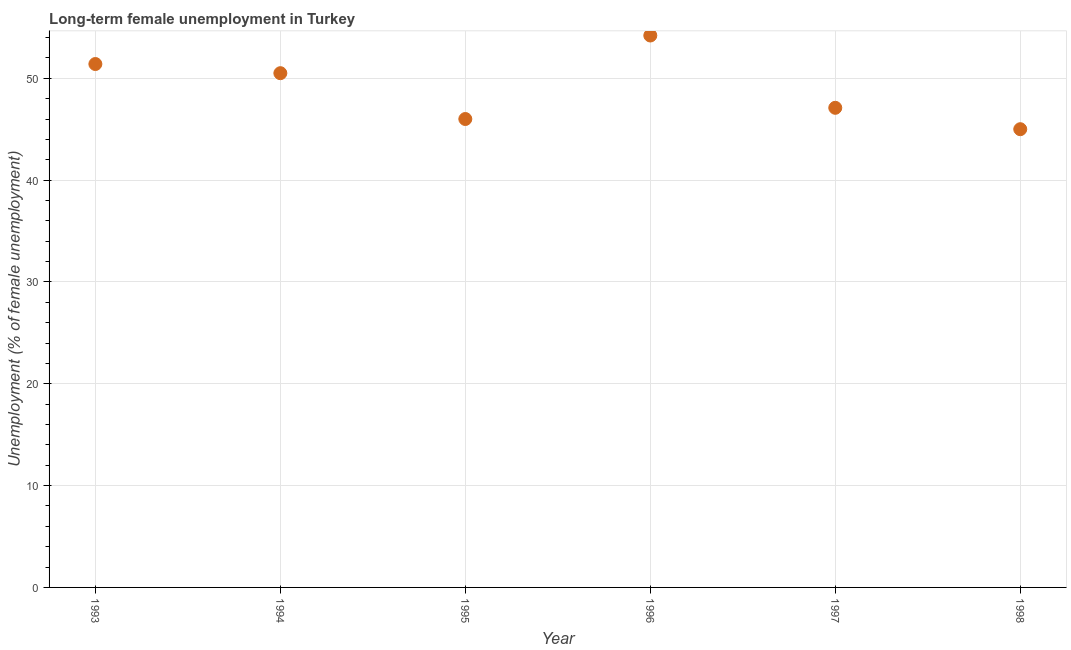Across all years, what is the maximum long-term female unemployment?
Your answer should be very brief. 54.2. Across all years, what is the minimum long-term female unemployment?
Provide a succinct answer. 45. In which year was the long-term female unemployment maximum?
Ensure brevity in your answer.  1996. What is the sum of the long-term female unemployment?
Keep it short and to the point. 294.2. What is the difference between the long-term female unemployment in 1996 and 1998?
Your answer should be compact. 9.2. What is the average long-term female unemployment per year?
Your answer should be compact. 49.03. What is the median long-term female unemployment?
Provide a short and direct response. 48.8. In how many years, is the long-term female unemployment greater than 34 %?
Ensure brevity in your answer.  6. Do a majority of the years between 1996 and 1993 (inclusive) have long-term female unemployment greater than 18 %?
Offer a terse response. Yes. What is the ratio of the long-term female unemployment in 1993 to that in 1997?
Offer a very short reply. 1.09. Is the long-term female unemployment in 1993 less than that in 1995?
Provide a short and direct response. No. What is the difference between the highest and the second highest long-term female unemployment?
Your answer should be very brief. 2.8. What is the difference between the highest and the lowest long-term female unemployment?
Your answer should be compact. 9.2. How many years are there in the graph?
Provide a short and direct response. 6. Are the values on the major ticks of Y-axis written in scientific E-notation?
Your answer should be very brief. No. What is the title of the graph?
Provide a succinct answer. Long-term female unemployment in Turkey. What is the label or title of the X-axis?
Offer a terse response. Year. What is the label or title of the Y-axis?
Give a very brief answer. Unemployment (% of female unemployment). What is the Unemployment (% of female unemployment) in 1993?
Your answer should be compact. 51.4. What is the Unemployment (% of female unemployment) in 1994?
Provide a short and direct response. 50.5. What is the Unemployment (% of female unemployment) in 1995?
Offer a very short reply. 46. What is the Unemployment (% of female unemployment) in 1996?
Ensure brevity in your answer.  54.2. What is the Unemployment (% of female unemployment) in 1997?
Ensure brevity in your answer.  47.1. What is the Unemployment (% of female unemployment) in 1998?
Offer a very short reply. 45. What is the difference between the Unemployment (% of female unemployment) in 1993 and 1995?
Provide a short and direct response. 5.4. What is the difference between the Unemployment (% of female unemployment) in 1993 and 1996?
Provide a succinct answer. -2.8. What is the difference between the Unemployment (% of female unemployment) in 1993 and 1998?
Give a very brief answer. 6.4. What is the difference between the Unemployment (% of female unemployment) in 1994 and 1995?
Offer a terse response. 4.5. What is the difference between the Unemployment (% of female unemployment) in 1994 and 1998?
Keep it short and to the point. 5.5. What is the difference between the Unemployment (% of female unemployment) in 1995 and 1996?
Offer a terse response. -8.2. What is the difference between the Unemployment (% of female unemployment) in 1996 and 1998?
Your response must be concise. 9.2. What is the difference between the Unemployment (% of female unemployment) in 1997 and 1998?
Your response must be concise. 2.1. What is the ratio of the Unemployment (% of female unemployment) in 1993 to that in 1995?
Provide a short and direct response. 1.12. What is the ratio of the Unemployment (% of female unemployment) in 1993 to that in 1996?
Your answer should be compact. 0.95. What is the ratio of the Unemployment (% of female unemployment) in 1993 to that in 1997?
Your answer should be very brief. 1.09. What is the ratio of the Unemployment (% of female unemployment) in 1993 to that in 1998?
Your response must be concise. 1.14. What is the ratio of the Unemployment (% of female unemployment) in 1994 to that in 1995?
Your answer should be very brief. 1.1. What is the ratio of the Unemployment (% of female unemployment) in 1994 to that in 1996?
Provide a short and direct response. 0.93. What is the ratio of the Unemployment (% of female unemployment) in 1994 to that in 1997?
Offer a terse response. 1.07. What is the ratio of the Unemployment (% of female unemployment) in 1994 to that in 1998?
Your response must be concise. 1.12. What is the ratio of the Unemployment (% of female unemployment) in 1995 to that in 1996?
Your answer should be very brief. 0.85. What is the ratio of the Unemployment (% of female unemployment) in 1995 to that in 1997?
Provide a short and direct response. 0.98. What is the ratio of the Unemployment (% of female unemployment) in 1995 to that in 1998?
Provide a succinct answer. 1.02. What is the ratio of the Unemployment (% of female unemployment) in 1996 to that in 1997?
Your answer should be very brief. 1.15. What is the ratio of the Unemployment (% of female unemployment) in 1996 to that in 1998?
Your answer should be compact. 1.2. What is the ratio of the Unemployment (% of female unemployment) in 1997 to that in 1998?
Your answer should be compact. 1.05. 